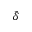Convert formula to latex. <formula><loc_0><loc_0><loc_500><loc_500>\tilde { \delta }</formula> 